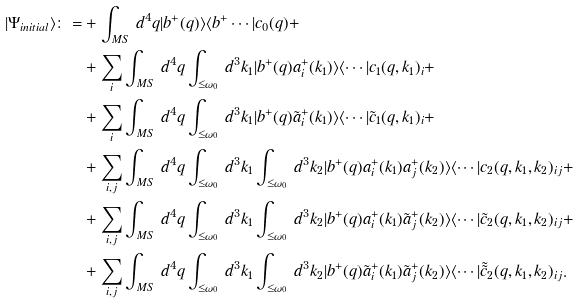Convert formula to latex. <formula><loc_0><loc_0><loc_500><loc_500>| \Psi _ { i n i t i a l } \rangle \colon = & + \int _ { M S } \, d ^ { 4 } q | b ^ { + } ( q ) \rangle \langle b ^ { + } \cdots | c _ { 0 } ( q ) + \\ & + \sum _ { i } \int _ { M S } \, d ^ { 4 } q \int _ { \leq \omega _ { 0 } } \, d ^ { 3 } k _ { 1 } | b ^ { + } ( q ) a ^ { + } _ { i } ( k _ { 1 } ) \rangle \langle \cdots | c _ { 1 } ( q , k _ { 1 } ) _ { i } + \\ & + \sum _ { i } \int _ { M S } \, d ^ { 4 } q \int _ { \leq \omega _ { 0 } } \, d ^ { 3 } k _ { 1 } | b ^ { + } ( q ) \tilde { a } ^ { + } _ { i } ( k _ { 1 } ) \rangle \langle \cdots | \tilde { c } _ { 1 } ( q , k _ { 1 } ) _ { i } + \\ & + \sum _ { i , j } \int _ { M S } \, d ^ { 4 } q \int _ { \leq \omega _ { 0 } } \, d ^ { 3 } k _ { 1 } \int _ { \leq \omega _ { 0 } } \, d ^ { 3 } k _ { 2 } | b ^ { + } ( q ) a ^ { + } _ { i } ( k _ { 1 } ) a ^ { + } _ { j } ( k _ { 2 } ) \rangle \langle \cdots | c _ { 2 } ( q , k _ { 1 } , k _ { 2 } ) _ { i j } + \\ & + \sum _ { i , j } \int _ { M S } \, d ^ { 4 } q \int _ { \leq \omega _ { 0 } } \, d ^ { 3 } k _ { 1 } \int _ { \leq \omega _ { 0 } } \, d ^ { 3 } k _ { 2 } | b ^ { + } ( q ) a ^ { + } _ { i } ( k _ { 1 } ) \tilde { a } ^ { + } _ { j } ( k _ { 2 } ) \rangle \langle \cdots | \tilde { c } _ { 2 } ( q , k _ { 1 } , k _ { 2 } ) _ { i j } + \\ & + \sum _ { i , j } \int _ { M S } \, d ^ { 4 } q \int _ { \leq \omega _ { 0 } } \, d ^ { 3 } k _ { 1 } \int _ { \leq \omega _ { 0 } } \, d ^ { 3 } k _ { 2 } | b ^ { + } ( q ) \tilde { a } ^ { + } _ { i } ( k _ { 1 } ) \tilde { a } ^ { + } _ { j } ( k _ { 2 } ) \rangle \langle \cdots | \tilde { \tilde { c } } _ { 2 } ( q , k _ { 1 } , k _ { 2 } ) _ { i j } .</formula> 